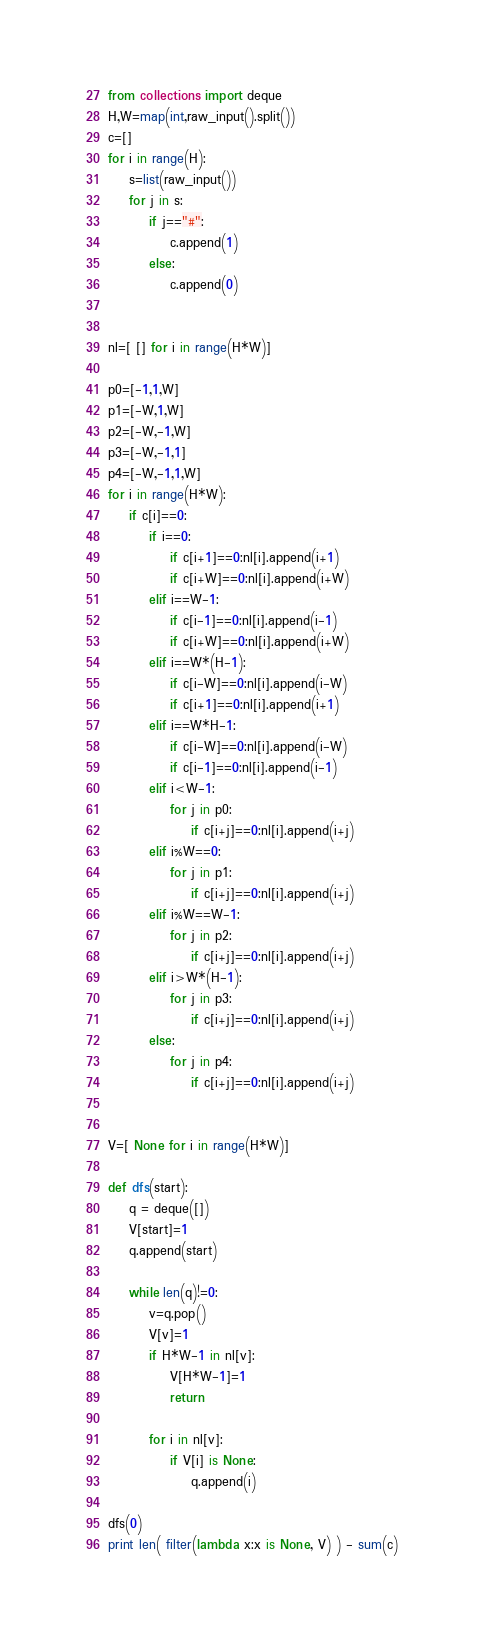<code> <loc_0><loc_0><loc_500><loc_500><_Python_>from collections import deque
H,W=map(int,raw_input().split())
c=[]
for i in range(H):
	s=list(raw_input())
	for j in s:
		if j=="#":
			c.append(1)
		else:
			c.append(0)


nl=[ [] for i in range(H*W)]

p0=[-1,1,W]
p1=[-W,1,W]
p2=[-W,-1,W]
p3=[-W,-1,1]
p4=[-W,-1,1,W]
for i in range(H*W):
	if c[i]==0:
		if i==0:
			if c[i+1]==0:nl[i].append(i+1)
			if c[i+W]==0:nl[i].append(i+W)
		elif i==W-1:
			if c[i-1]==0:nl[i].append(i-1)
			if c[i+W]==0:nl[i].append(i+W)
		elif i==W*(H-1):
			if c[i-W]==0:nl[i].append(i-W)
			if c[i+1]==0:nl[i].append(i+1)		
		elif i==W*H-1:
			if c[i-W]==0:nl[i].append(i-W)
			if c[i-1]==0:nl[i].append(i-1)
		elif i<W-1:
			for j in p0:
				if c[i+j]==0:nl[i].append(i+j)			
		elif i%W==0:
			for j in p1:
				if c[i+j]==0:nl[i].append(i+j)	
		elif i%W==W-1:
			for j in p2:
				if c[i+j]==0:nl[i].append(i+j)
		elif i>W*(H-1):
			for j in p3:
				if c[i+j]==0:nl[i].append(i+j)
		else:
			for j in p4:
				if c[i+j]==0:nl[i].append(i+j)
				

V=[ None for i in range(H*W)]

def dfs(start):
	q = deque([]) 
	V[start]=1
	q.append(start)

	while len(q)!=0:
		v=q.pop()
		V[v]=1
		if H*W-1 in nl[v]:
			V[H*W-1]=1
			return

		for i in nl[v]:
			if V[i] is None:
				q.append(i)

dfs(0)
print len( filter(lambda x:x is None, V) ) - sum(c)


</code> 